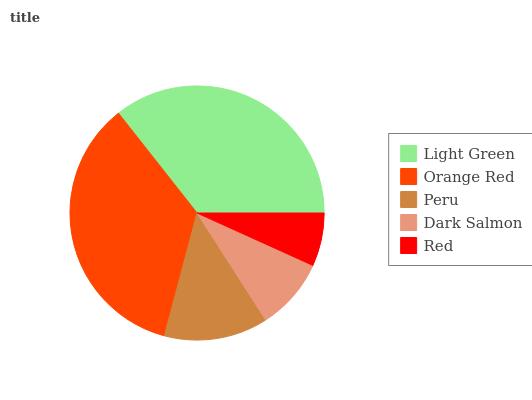Is Red the minimum?
Answer yes or no. Yes. Is Light Green the maximum?
Answer yes or no. Yes. Is Orange Red the minimum?
Answer yes or no. No. Is Orange Red the maximum?
Answer yes or no. No. Is Light Green greater than Orange Red?
Answer yes or no. Yes. Is Orange Red less than Light Green?
Answer yes or no. Yes. Is Orange Red greater than Light Green?
Answer yes or no. No. Is Light Green less than Orange Red?
Answer yes or no. No. Is Peru the high median?
Answer yes or no. Yes. Is Peru the low median?
Answer yes or no. Yes. Is Light Green the high median?
Answer yes or no. No. Is Light Green the low median?
Answer yes or no. No. 